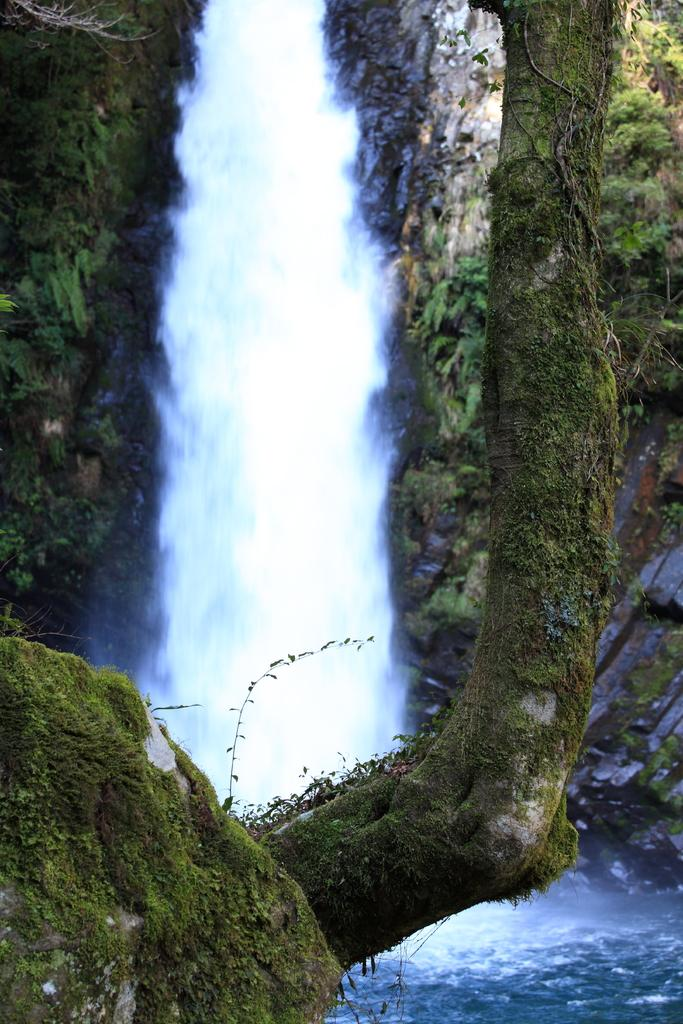What is the main feature in the middle of the image? There is a waterfall in the middle of the image. What can be seen near the waterfall? There are plants beside the waterfall. What is present at the bottom of the waterfall? There is algae on a stone at the bottom of the waterfall. What songs are being sung by the kittens in the image? There are no kittens present in the image, so there are no songs being sung. 